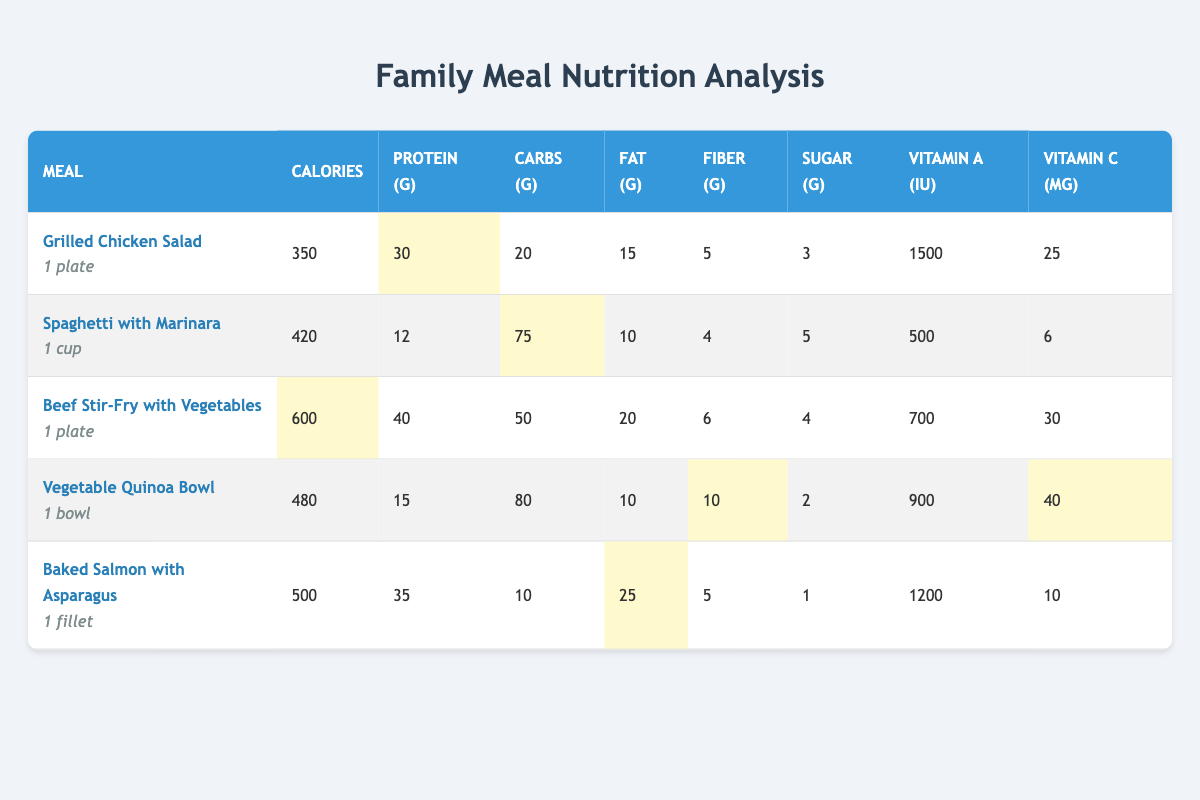What meal has the highest calories? The table lists the calorie contents for each meal. By comparing the calorie values, the Beef Stir-Fry with Vegetables has the highest calories at 600.
Answer: Beef Stir-Fry with Vegetables Which meal contains the most protein? The protein values are compared across all meals listed in the table. The Beef Stir-Fry with Vegetables has the most protein at 40 grams.
Answer: Beef Stir-Fry with Vegetables How many total grams of carbohydrates are in all the meals combined? To find the total carbohydrates, I add the carbohydrate grams from each meal: 20 + 75 + 50 + 80 + 10 = 235 grams.
Answer: 235 grams Is the sugar content of Grilled Chicken Salad lower than that of Baked Salmon with Asparagus? The sugar content of Grilled Chicken Salad is 3 grams, and for Baked Salmon with Asparagus, it is 1 gram. Since 3 is greater than 1, the sugar content of Grilled Chicken Salad is not lower.
Answer: No What meal has the highest vitamin C content? By checking the vitamin C content in the table, the Vegetable Quinoa Bowl has the highest vitamin C at 40 mg.
Answer: Vegetable Quinoa Bowl What is the average calorie content of all the meals? To find the average calories, I sum the calorie values: 350 + 420 + 600 + 480 + 500 = 2350, then divide by the number of meals (5), giving an average of 470 calories.
Answer: 470 calories Is there a meal that has both high protein and low carbohydrates? Analyzing meals for high protein and low carbohydrates shows that Baked Salmon with Asparagus has 35 grams of protein and only 10 grams of carbohydrates, indicating it fits the criteria.
Answer: Yes What is the difference in fiber content between the meal with the most fiber and the one with the least fiber? The Vegetable Quinoa Bowl has the most fiber at 10 grams, and Spaghetti with Marinara has the least fiber at 4 grams. The difference is 10 - 4 = 6 grams.
Answer: 6 grams Which meal has more Vitamin A: Grilled Chicken Salad or Baked Salmon with Asparagus? Grilled Chicken Salad has 1500 IU of Vitamin A, while Baked Salmon with Asparagus has 1200 IU. Since 1500 is greater than 1200, Grilled Chicken Salad has more Vitamin A.
Answer: Grilled Chicken Salad 